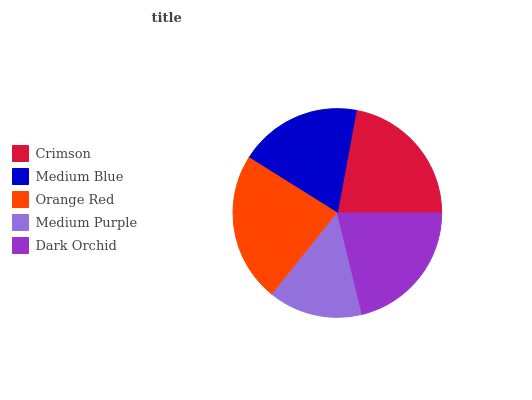Is Medium Purple the minimum?
Answer yes or no. Yes. Is Orange Red the maximum?
Answer yes or no. Yes. Is Medium Blue the minimum?
Answer yes or no. No. Is Medium Blue the maximum?
Answer yes or no. No. Is Crimson greater than Medium Blue?
Answer yes or no. Yes. Is Medium Blue less than Crimson?
Answer yes or no. Yes. Is Medium Blue greater than Crimson?
Answer yes or no. No. Is Crimson less than Medium Blue?
Answer yes or no. No. Is Dark Orchid the high median?
Answer yes or no. Yes. Is Dark Orchid the low median?
Answer yes or no. Yes. Is Medium Purple the high median?
Answer yes or no. No. Is Orange Red the low median?
Answer yes or no. No. 